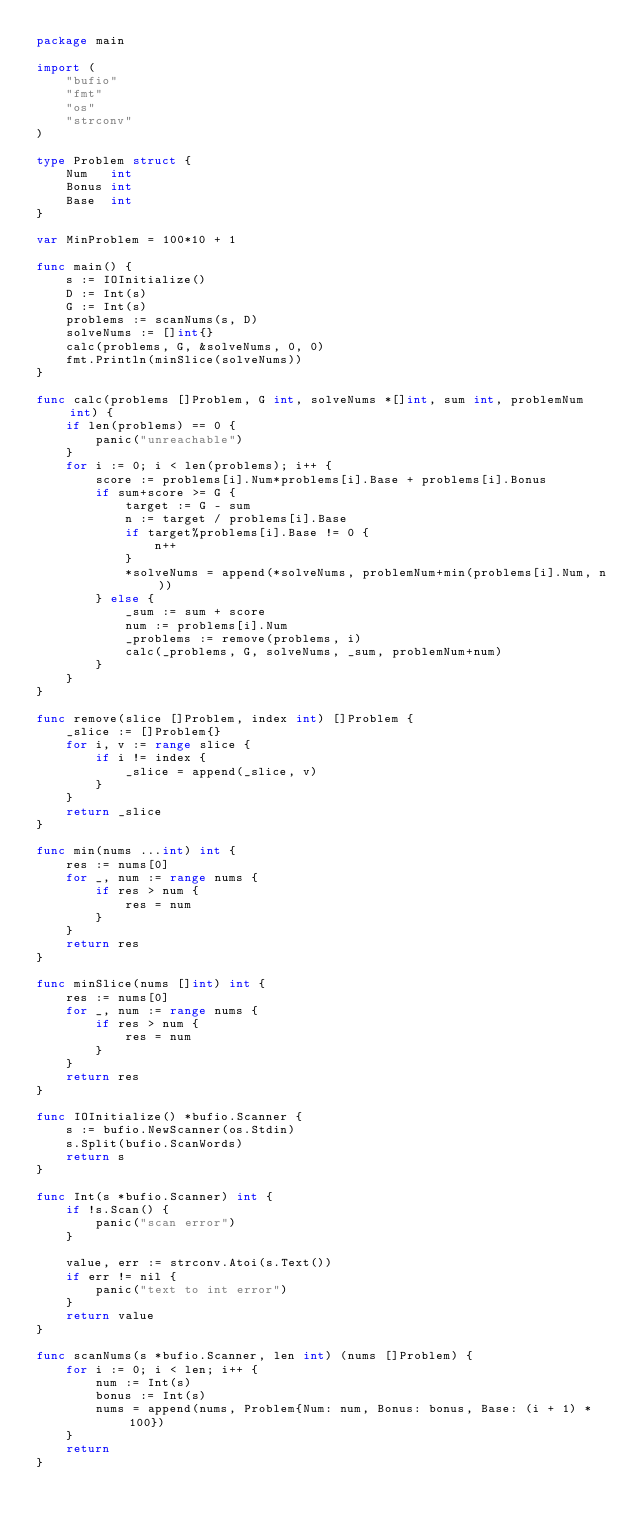<code> <loc_0><loc_0><loc_500><loc_500><_Go_>package main

import (
	"bufio"
	"fmt"
	"os"
	"strconv"
)

type Problem struct {
	Num   int
	Bonus int
	Base  int
}

var MinProblem = 100*10 + 1

func main() {
	s := IOInitialize()
	D := Int(s)
	G := Int(s)
	problems := scanNums(s, D)
	solveNums := []int{}
	calc(problems, G, &solveNums, 0, 0)
	fmt.Println(minSlice(solveNums))
}

func calc(problems []Problem, G int, solveNums *[]int, sum int, problemNum int) {
	if len(problems) == 0 {
		panic("unreachable")
	}
	for i := 0; i < len(problems); i++ {
		score := problems[i].Num*problems[i].Base + problems[i].Bonus
		if sum+score >= G {
			target := G - sum
			n := target / problems[i].Base
			if target%problems[i].Base != 0 {
				n++
			}
			*solveNums = append(*solveNums, problemNum+min(problems[i].Num, n))
		} else {
			_sum := sum + score
			num := problems[i].Num
			_problems := remove(problems, i)
			calc(_problems, G, solveNums, _sum, problemNum+num)
		}
	}
}

func remove(slice []Problem, index int) []Problem {
	_slice := []Problem{}
	for i, v := range slice {
		if i != index {
			_slice = append(_slice, v)
		}
	}
	return _slice
}

func min(nums ...int) int {
	res := nums[0]
	for _, num := range nums {
		if res > num {
			res = num
		}
	}
	return res
}

func minSlice(nums []int) int {
	res := nums[0]
	for _, num := range nums {
		if res > num {
			res = num
		}
	}
	return res
}

func IOInitialize() *bufio.Scanner {
	s := bufio.NewScanner(os.Stdin)
	s.Split(bufio.ScanWords)
	return s
}

func Int(s *bufio.Scanner) int {
	if !s.Scan() {
		panic("scan error")
	}

	value, err := strconv.Atoi(s.Text())
	if err != nil {
		panic("text to int error")
	}
	return value
}

func scanNums(s *bufio.Scanner, len int) (nums []Problem) {
	for i := 0; i < len; i++ {
		num := Int(s)
		bonus := Int(s)
		nums = append(nums, Problem{Num: num, Bonus: bonus, Base: (i + 1) * 100})
	}
	return
}
</code> 